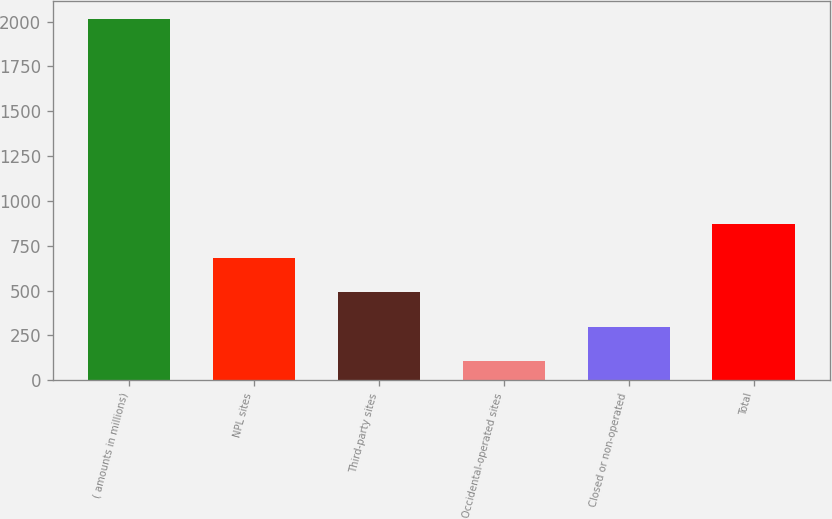Convert chart. <chart><loc_0><loc_0><loc_500><loc_500><bar_chart><fcel>( amounts in millions)<fcel>NPL sites<fcel>Third-party sites<fcel>Occidental-operated sites<fcel>Closed or non-operated<fcel>Total<nl><fcel>2017<fcel>680.7<fcel>489.8<fcel>108<fcel>298.9<fcel>871.6<nl></chart> 